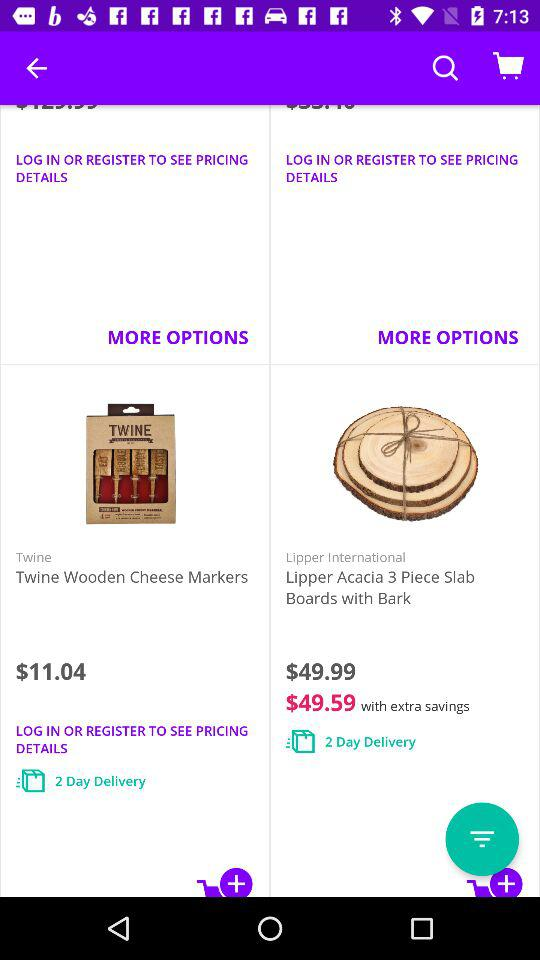What is the price of a "Lipper Acacia 3 Piece Slab"? The price of a "Lipper Acacia 3 Piece Slab" is $49.99. 